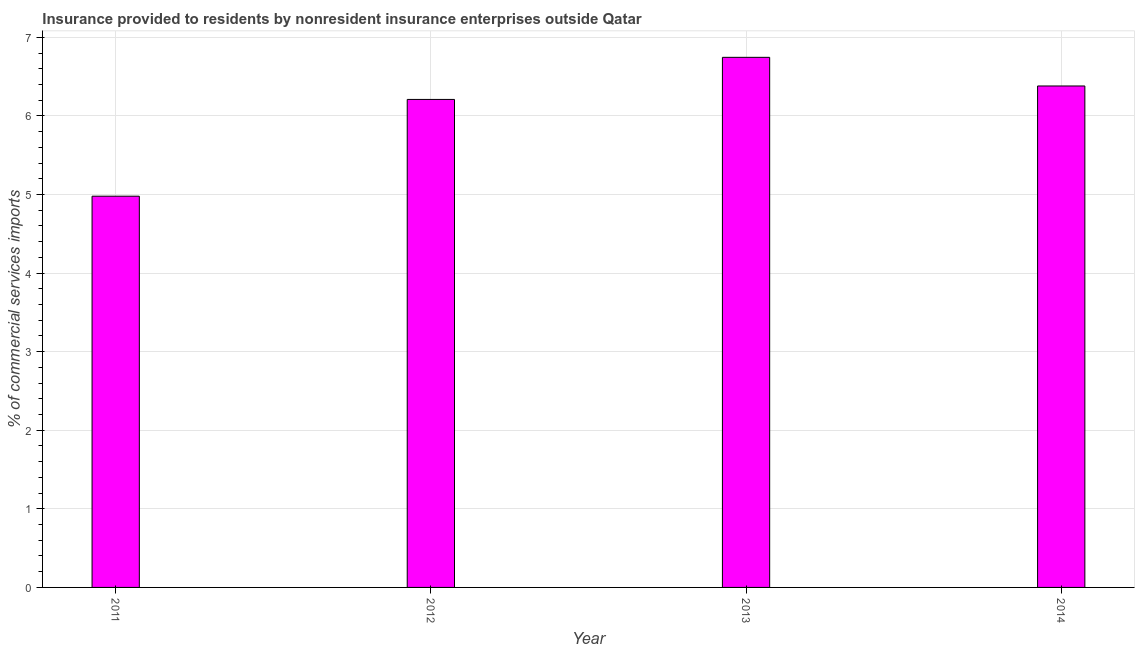Does the graph contain any zero values?
Ensure brevity in your answer.  No. What is the title of the graph?
Keep it short and to the point. Insurance provided to residents by nonresident insurance enterprises outside Qatar. What is the label or title of the X-axis?
Your answer should be very brief. Year. What is the label or title of the Y-axis?
Offer a terse response. % of commercial services imports. What is the insurance provided by non-residents in 2014?
Provide a short and direct response. 6.38. Across all years, what is the maximum insurance provided by non-residents?
Give a very brief answer. 6.75. Across all years, what is the minimum insurance provided by non-residents?
Provide a short and direct response. 4.98. In which year was the insurance provided by non-residents minimum?
Offer a very short reply. 2011. What is the sum of the insurance provided by non-residents?
Give a very brief answer. 24.32. What is the difference between the insurance provided by non-residents in 2011 and 2012?
Your response must be concise. -1.23. What is the average insurance provided by non-residents per year?
Offer a terse response. 6.08. What is the median insurance provided by non-residents?
Make the answer very short. 6.3. In how many years, is the insurance provided by non-residents greater than 4.8 %?
Provide a succinct answer. 4. Do a majority of the years between 2011 and 2012 (inclusive) have insurance provided by non-residents greater than 1.8 %?
Offer a terse response. Yes. What is the ratio of the insurance provided by non-residents in 2011 to that in 2014?
Keep it short and to the point. 0.78. Is the difference between the insurance provided by non-residents in 2011 and 2012 greater than the difference between any two years?
Provide a succinct answer. No. What is the difference between the highest and the second highest insurance provided by non-residents?
Offer a very short reply. 0.36. What is the difference between the highest and the lowest insurance provided by non-residents?
Give a very brief answer. 1.77. How many bars are there?
Provide a short and direct response. 4. What is the difference between two consecutive major ticks on the Y-axis?
Your response must be concise. 1. What is the % of commercial services imports in 2011?
Offer a very short reply. 4.98. What is the % of commercial services imports of 2012?
Your answer should be very brief. 6.21. What is the % of commercial services imports in 2013?
Offer a terse response. 6.75. What is the % of commercial services imports of 2014?
Provide a succinct answer. 6.38. What is the difference between the % of commercial services imports in 2011 and 2012?
Your response must be concise. -1.23. What is the difference between the % of commercial services imports in 2011 and 2013?
Provide a short and direct response. -1.77. What is the difference between the % of commercial services imports in 2011 and 2014?
Make the answer very short. -1.4. What is the difference between the % of commercial services imports in 2012 and 2013?
Make the answer very short. -0.54. What is the difference between the % of commercial services imports in 2012 and 2014?
Offer a terse response. -0.17. What is the difference between the % of commercial services imports in 2013 and 2014?
Make the answer very short. 0.36. What is the ratio of the % of commercial services imports in 2011 to that in 2012?
Ensure brevity in your answer.  0.8. What is the ratio of the % of commercial services imports in 2011 to that in 2013?
Offer a terse response. 0.74. What is the ratio of the % of commercial services imports in 2011 to that in 2014?
Your answer should be compact. 0.78. What is the ratio of the % of commercial services imports in 2012 to that in 2013?
Offer a terse response. 0.92. What is the ratio of the % of commercial services imports in 2012 to that in 2014?
Your answer should be very brief. 0.97. What is the ratio of the % of commercial services imports in 2013 to that in 2014?
Your answer should be very brief. 1.06. 